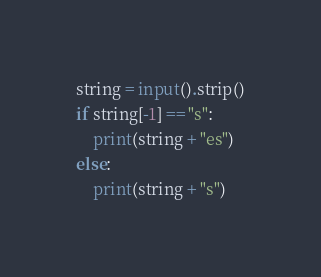Convert code to text. <code><loc_0><loc_0><loc_500><loc_500><_Python_>string = input().strip()
if string[-1] == "s":
    print(string + "es")
else:
    print(string + "s")
</code> 